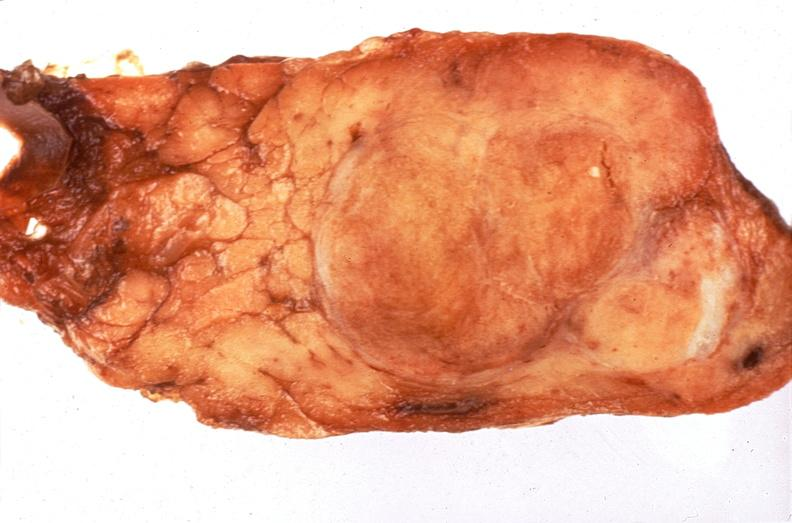what does this image show?
Answer the question using a single word or phrase. Pituitary 